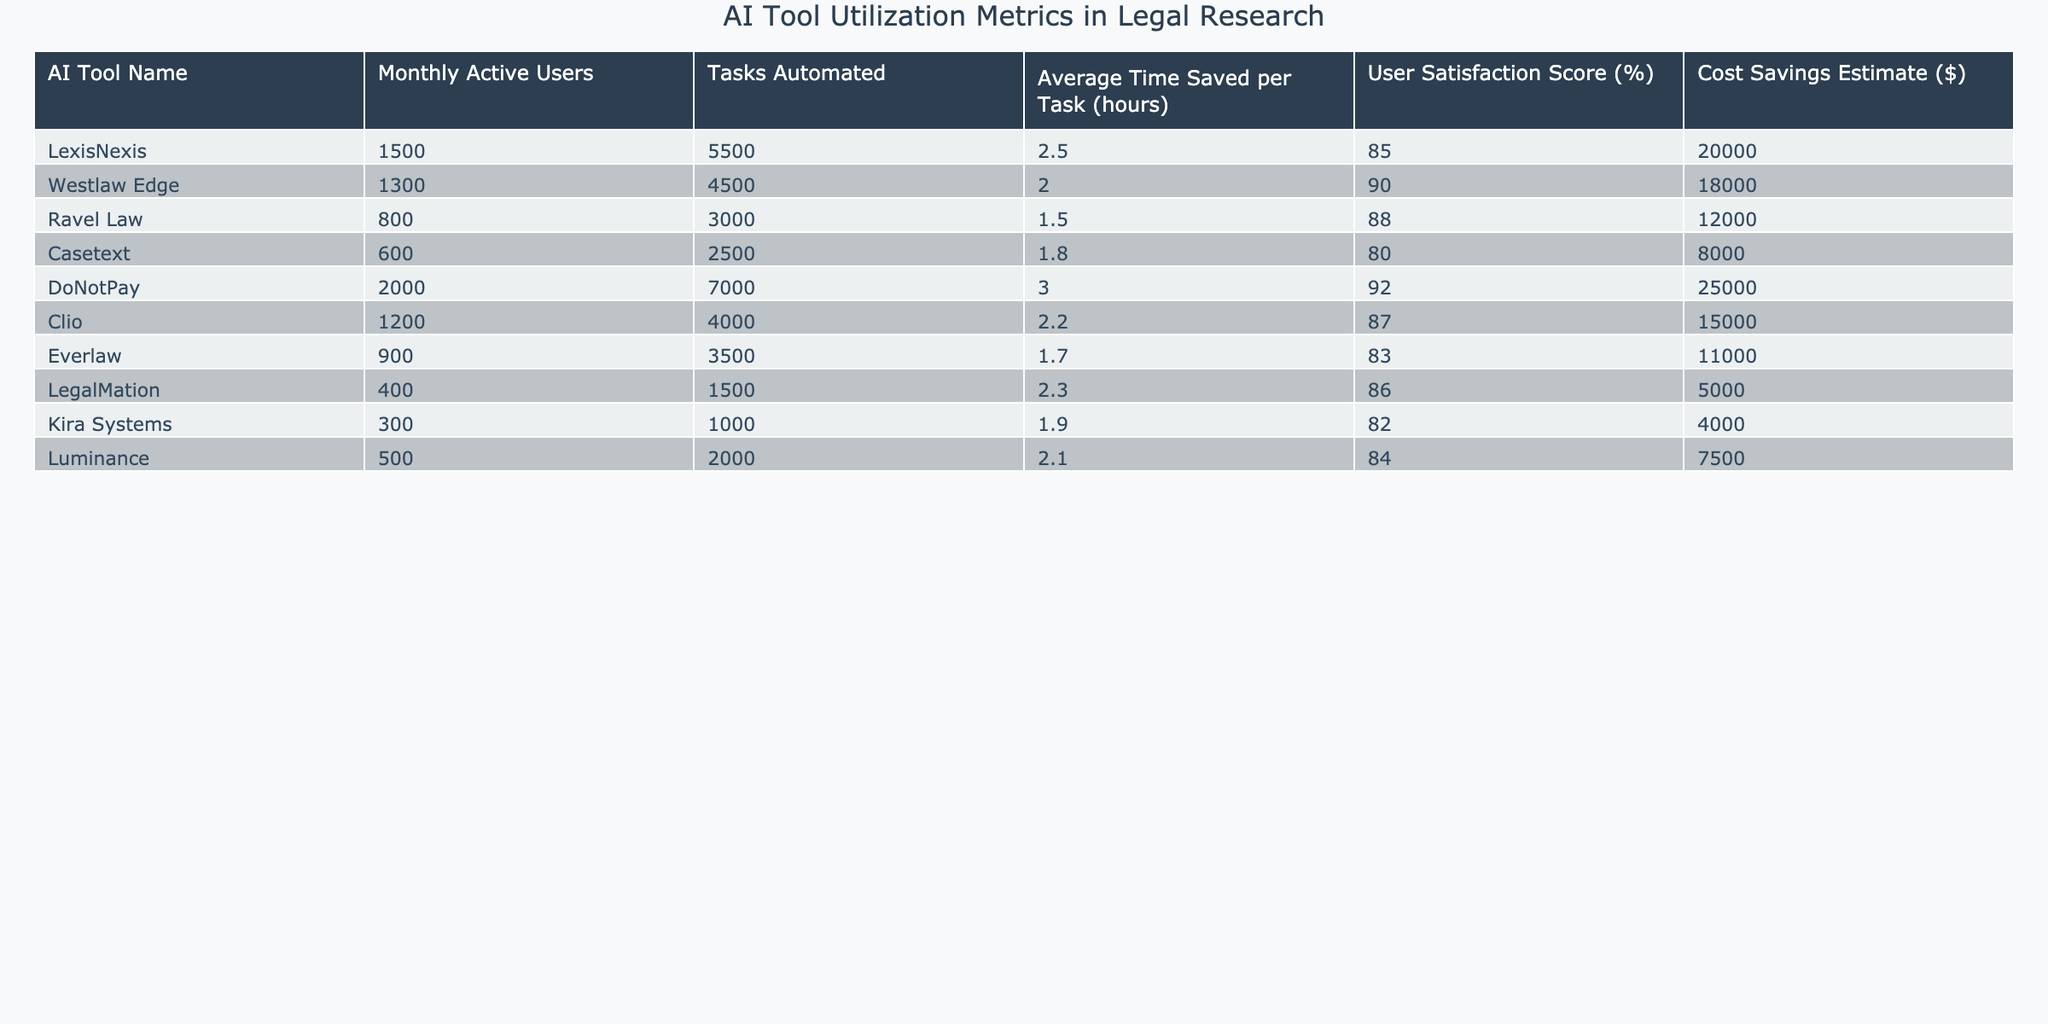What is the user satisfaction score for DoNotPay? The table lists the user satisfaction score for DoNotPay, which is clearly shown as 92%.
Answer: 92% Which AI tool has the highest cost savings estimate? By reviewing the cost savings estimates in the table, DoNotPay has the highest estimate at $25,000.
Answer: $25,000 What is the total number of tasks automated across all AI tools? We sum the tasks automated for all tools: 5500 + 4500 + 3000 + 2500 + 7000 + 4000 + 3500 + 1500 + 1000 + 2000 = 30,500 tasks automated.
Answer: 30,500 Is the average time saved per task for Westlaw Edge greater than for Luminance? The average time saved per task for Westlaw Edge is 2.0 hours, while for Luminance it is 2.1 hours, thus Westlaw Edge does not have a greater time saved.
Answer: No What is the difference in average time saved per task between the AI tools with the highest and lowest user satisfaction scores? The highest user satisfaction score is for DoNotPay at 92%, with an average time saved per task of 3.0 hours. The lowest score is for Casetext at 80%, with an average time saved of 1.8 hours. The difference is 3.0 - 1.8 = 1.2 hours.
Answer: 1.2 hours Which AI tool has the second highest number of monthly active users? The monthly active users for all tools are sorted, and the second highest is Westlaw Edge with 1300 monthly active users.
Answer: 1300 How many total hours did users save across all tasks automated? We calculate the total saved hours by multiplying the total tasks automated (30,500) by the average time saved per task. The average time can be estimated by considering the various averages; a rough average is about 2.0 hours. Thus, 30,500 * 2.0 ≈ 61,000 hours.
Answer: ≈ 61,000 hours Do any AI tools have a user satisfaction score below 80%? We check the user satisfaction scores listed: the only tool below 80% is Casetext with a score of 80%. Thus, no tool has a score below 80%.
Answer: No Which AI tool has a cost savings estimate less than $10,000? Upon reviewing the cost savings estimates in the table, the only tools with less than $10,000 are LegalMation ($5,000) and Kira Systems ($4,000).
Answer: LegalMation and Kira Systems What is the ratio of tasks automated by DoNotPay compared to Kira Systems? We find the tasks automated: DoNotPay has 7000 and Kira Systems has 1000. The ratio is 7000 / 1000 = 7.
Answer: 7 